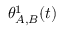Convert formula to latex. <formula><loc_0><loc_0><loc_500><loc_500>\theta _ { A , B } ^ { 1 } ( t )</formula> 